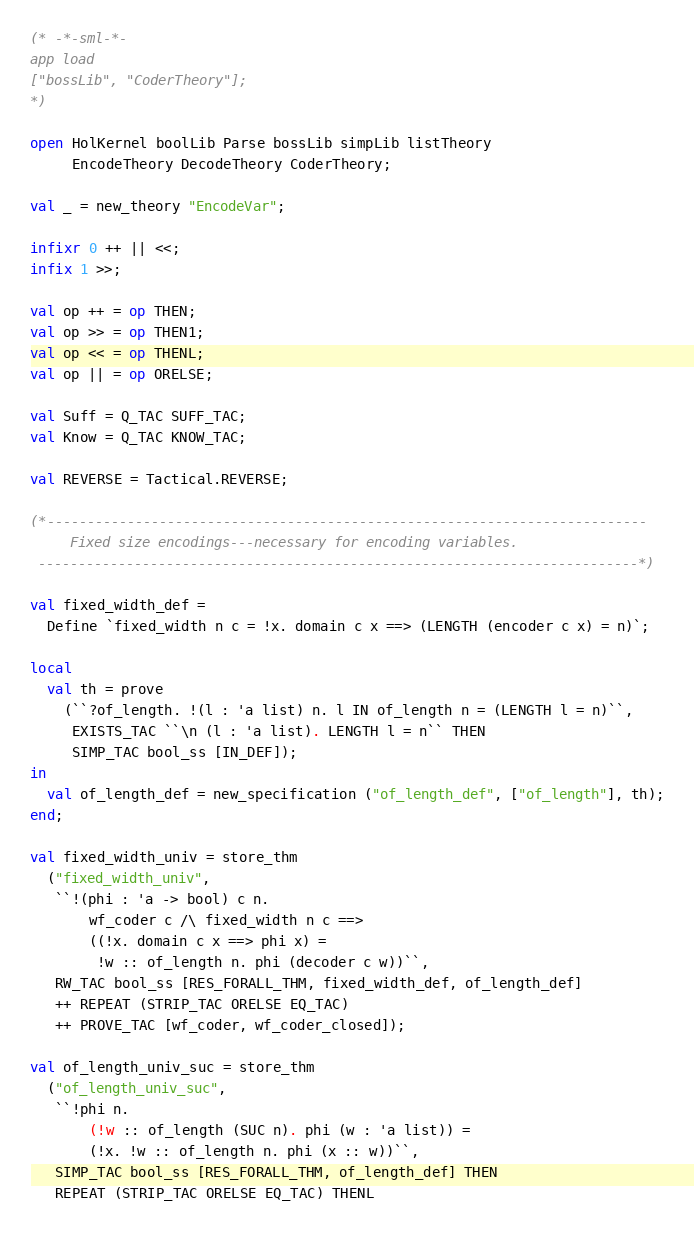<code> <loc_0><loc_0><loc_500><loc_500><_SML_>(* -*-sml-*-
app load
["bossLib", "CoderTheory"];
*)

open HolKernel boolLib Parse bossLib simpLib listTheory
     EncodeTheory DecodeTheory CoderTheory;

val _ = new_theory "EncodeVar";

infixr 0 ++ || <<;
infix 1 >>;

val op ++ = op THEN;
val op >> = op THEN1;
val op << = op THENL;
val op || = op ORELSE;

val Suff = Q_TAC SUFF_TAC;
val Know = Q_TAC KNOW_TAC;

val REVERSE = Tactical.REVERSE;

(*---------------------------------------------------------------------------
     Fixed size encodings---necessary for encoding variables.
 ---------------------------------------------------------------------------*)

val fixed_width_def =
  Define `fixed_width n c = !x. domain c x ==> (LENGTH (encoder c x) = n)`;

local
  val th = prove
    (``?of_length. !(l : 'a list) n. l IN of_length n = (LENGTH l = n)``,
     EXISTS_TAC ``\n (l : 'a list). LENGTH l = n`` THEN
     SIMP_TAC bool_ss [IN_DEF]);
in
  val of_length_def = new_specification ("of_length_def", ["of_length"], th);
end;

val fixed_width_univ = store_thm
  ("fixed_width_univ",
   ``!(phi : 'a -> bool) c n.
       wf_coder c /\ fixed_width n c ==>
       ((!x. domain c x ==> phi x) =
        !w :: of_length n. phi (decoder c w))``,
   RW_TAC bool_ss [RES_FORALL_THM, fixed_width_def, of_length_def]
   ++ REPEAT (STRIP_TAC ORELSE EQ_TAC)
   ++ PROVE_TAC [wf_coder, wf_coder_closed]);

val of_length_univ_suc = store_thm
  ("of_length_univ_suc",
   ``!phi n.
       (!w :: of_length (SUC n). phi (w : 'a list)) =
       (!x. !w :: of_length n. phi (x :: w))``,
   SIMP_TAC bool_ss [RES_FORALL_THM, of_length_def] THEN
   REPEAT (STRIP_TAC ORELSE EQ_TAC) THENL</code> 